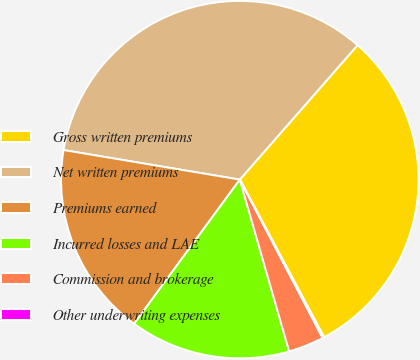<chart> <loc_0><loc_0><loc_500><loc_500><pie_chart><fcel>Gross written premiums<fcel>Net written premiums<fcel>Premiums earned<fcel>Incurred losses and LAE<fcel>Commission and brokerage<fcel>Other underwriting expenses<nl><fcel>30.73%<fcel>33.8%<fcel>17.58%<fcel>14.52%<fcel>3.22%<fcel>0.15%<nl></chart> 